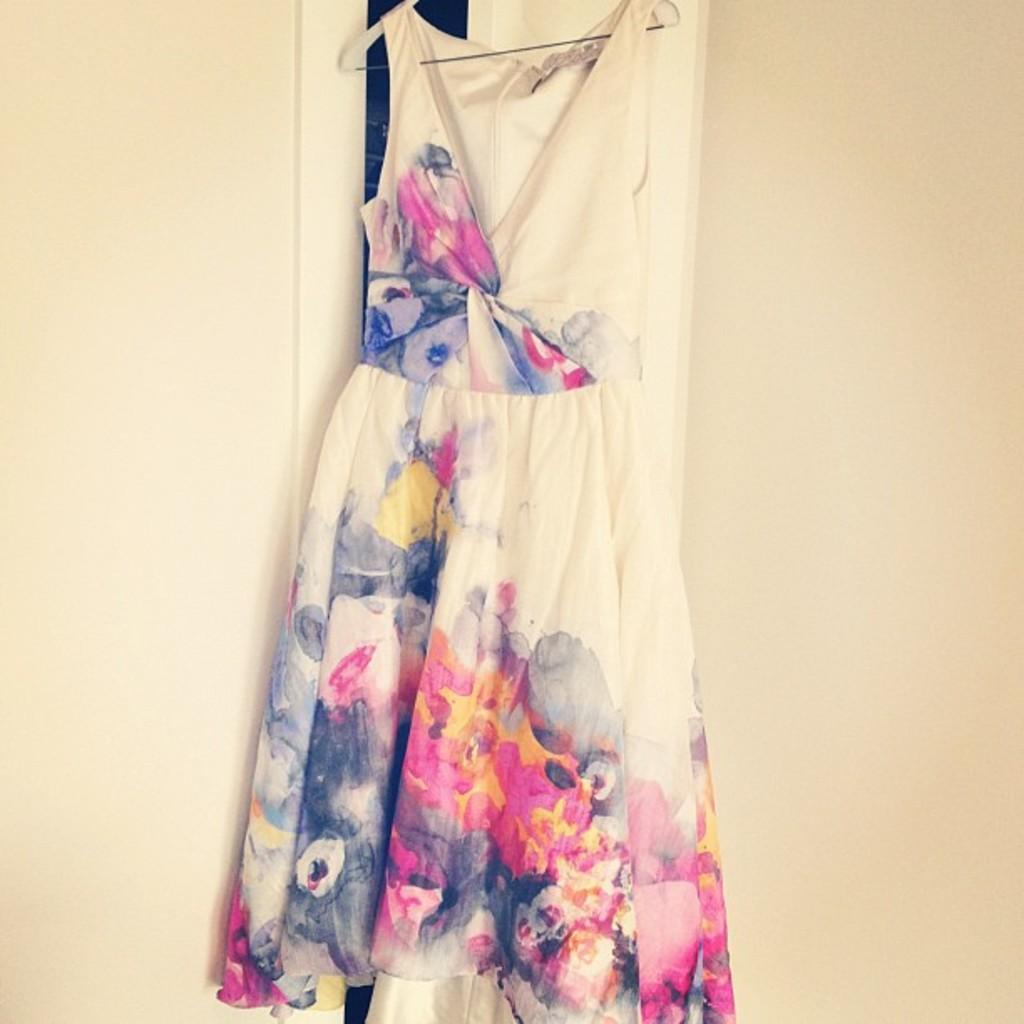What is hanging on the wall in the image? There is a dress on a hanger hanging on the wall. Can you describe the position of the dress in the image? The dress is hanging on a hanger, which is attached to the wall. What type of cheese is visible on the wall in the image? There is no cheese present in the image; it features a dress on a hanger hanging on a wall. 